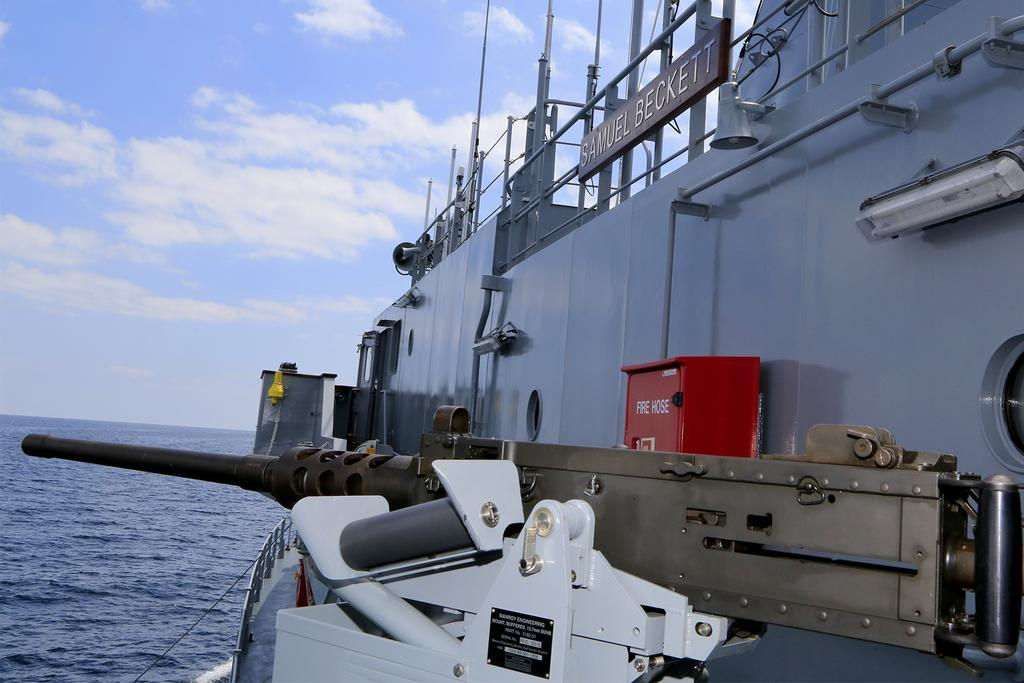What is the main subject of the image? There is a ship in the image. What colors can be seen on the ship? The ship is white, black, and grey in color. Where is the ship located in the image? The ship is on the surface of the water. What can be seen in the background of the image? The sky is visible in the background of the image. How many feet long is the word painted on the side of the ship? There is no word painted on the side of the ship in the image, so it is not possible to determine its length in feet. 